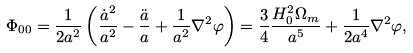<formula> <loc_0><loc_0><loc_500><loc_500>\Phi _ { 0 0 } = \frac { 1 } { 2 a ^ { 2 } } \left ( \frac { \dot { a } ^ { 2 } } { a ^ { 2 } } - \frac { \ddot { a } } { a } + \frac { 1 } { a ^ { 2 } } \nabla ^ { 2 } \varphi \right ) = \frac { 3 } { 4 } \frac { H _ { 0 } ^ { 2 } \Omega _ { m } } { a ^ { 5 } } + \frac { 1 } { 2 a ^ { 4 } } \nabla ^ { 2 } \varphi ,</formula> 